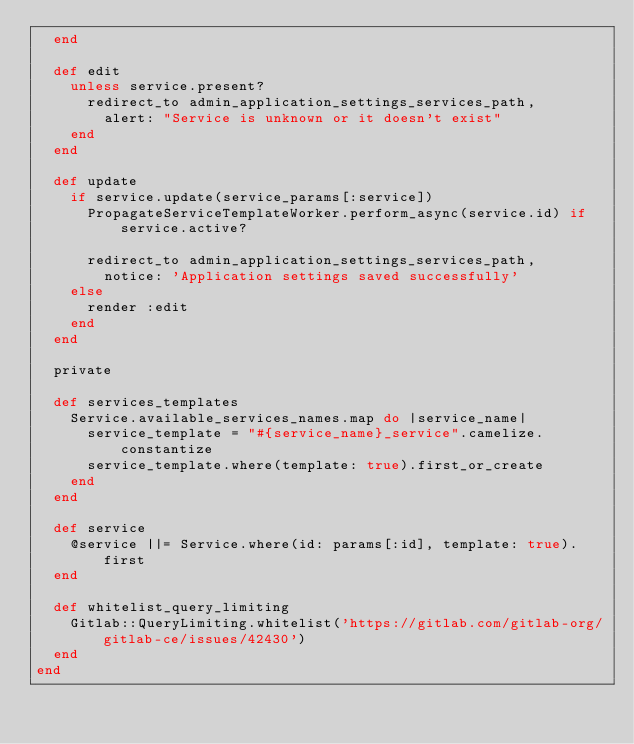Convert code to text. <code><loc_0><loc_0><loc_500><loc_500><_Ruby_>  end

  def edit
    unless service.present?
      redirect_to admin_application_settings_services_path,
        alert: "Service is unknown or it doesn't exist"
    end
  end

  def update
    if service.update(service_params[:service])
      PropagateServiceTemplateWorker.perform_async(service.id) if service.active?

      redirect_to admin_application_settings_services_path,
        notice: 'Application settings saved successfully'
    else
      render :edit
    end
  end

  private

  def services_templates
    Service.available_services_names.map do |service_name|
      service_template = "#{service_name}_service".camelize.constantize
      service_template.where(template: true).first_or_create
    end
  end

  def service
    @service ||= Service.where(id: params[:id], template: true).first
  end

  def whitelist_query_limiting
    Gitlab::QueryLimiting.whitelist('https://gitlab.com/gitlab-org/gitlab-ce/issues/42430')
  end
end
</code> 